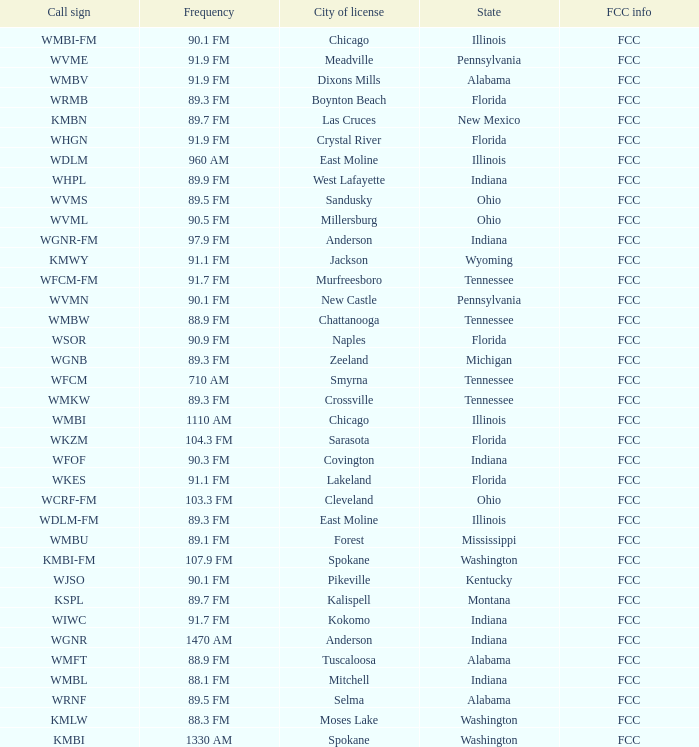What state is the radio station in that has a frequency of 90.1 FM and a city license in New Castle? Pennsylvania. 